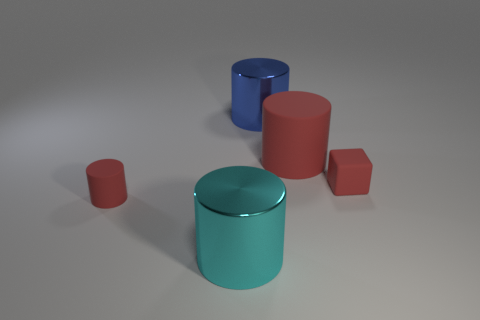Subtract all big cyan cylinders. How many cylinders are left? 3 Subtract all cyan cylinders. How many cylinders are left? 3 Subtract all cyan blocks. How many red cylinders are left? 2 Add 4 tiny rubber cubes. How many objects exist? 9 Subtract 3 cylinders. How many cylinders are left? 1 Subtract 0 purple balls. How many objects are left? 5 Subtract all blocks. How many objects are left? 4 Subtract all brown blocks. Subtract all red spheres. How many blocks are left? 1 Subtract all big cyan things. Subtract all big cyan cubes. How many objects are left? 4 Add 5 big red matte objects. How many big red matte objects are left? 6 